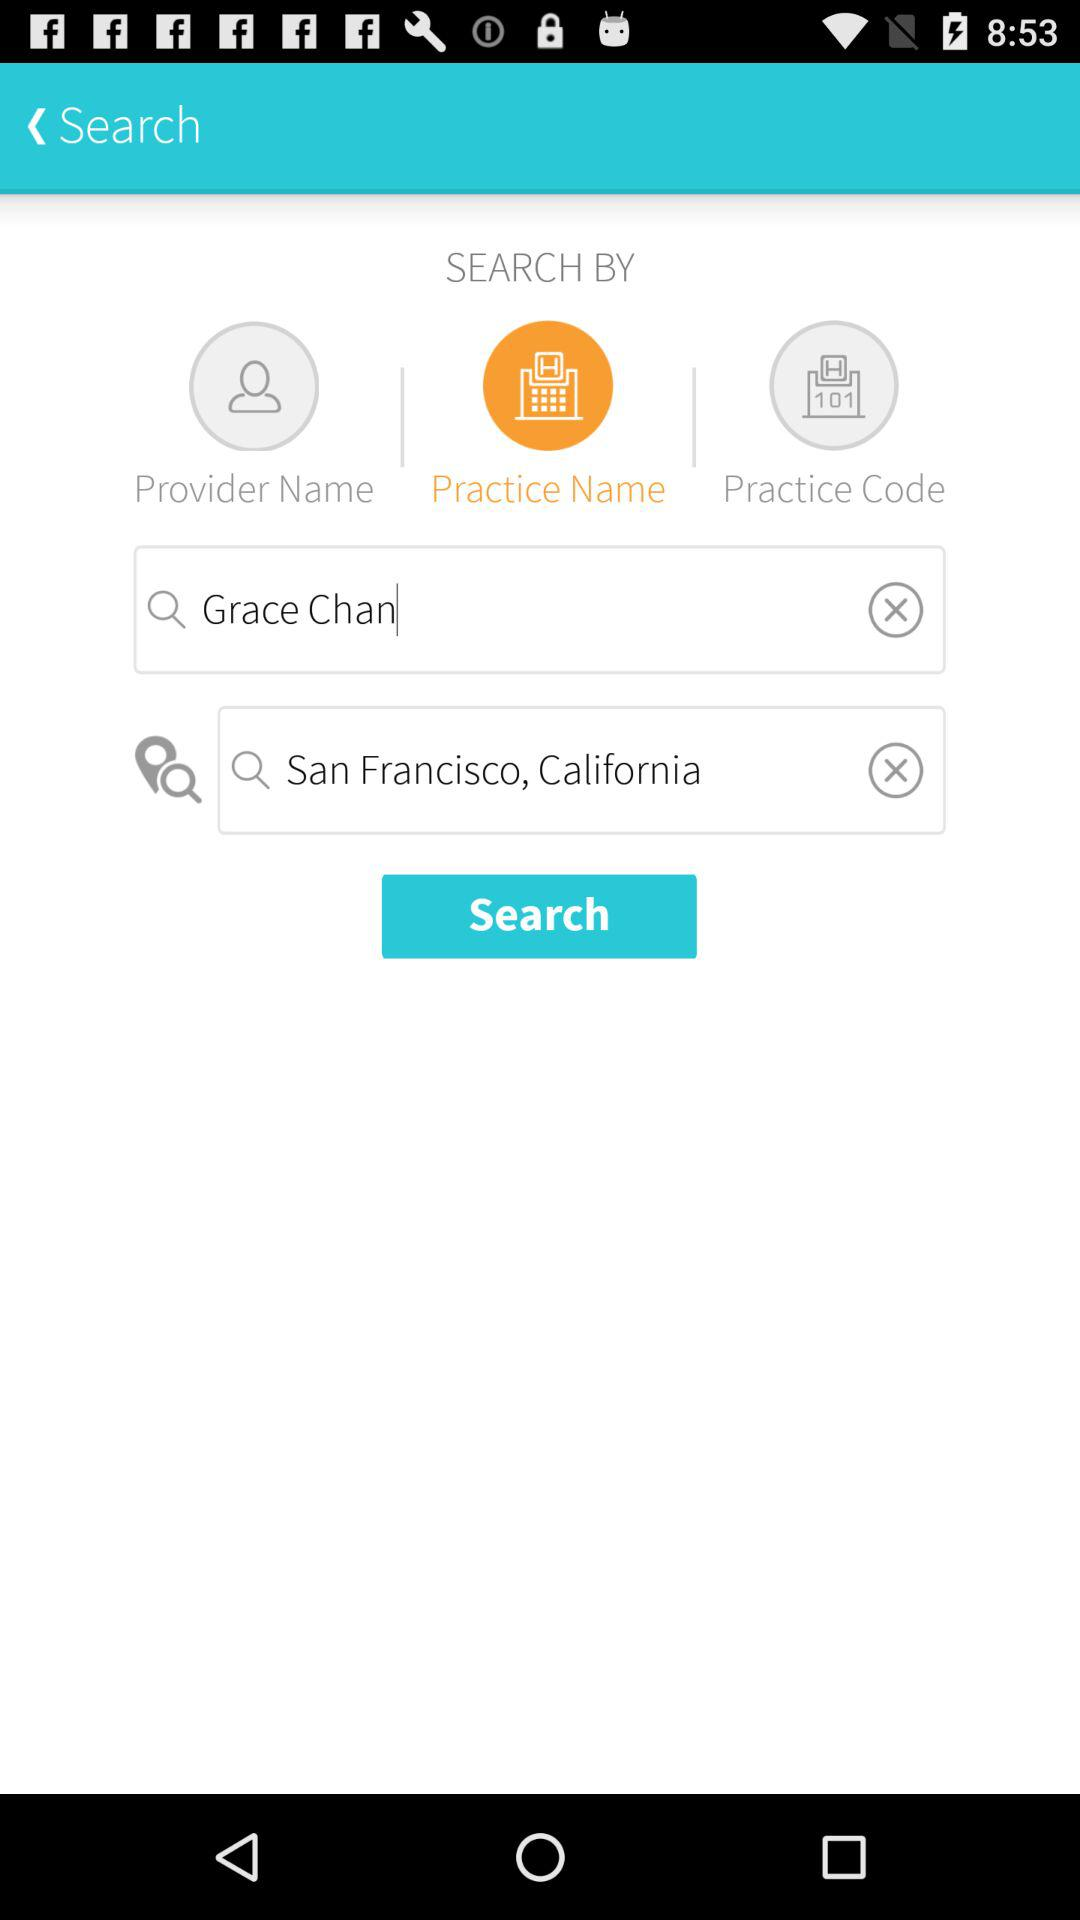What option has been selected? The selected option is "Practice Name". 